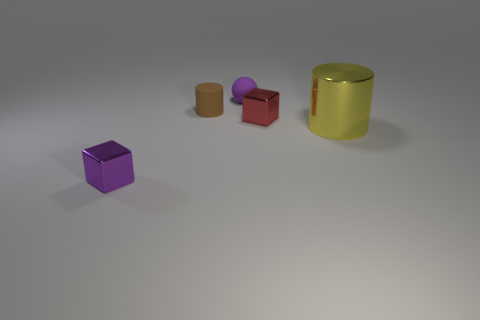Add 1 small purple spheres. How many objects exist? 6 Subtract all purple cubes. How many cubes are left? 1 Subtract 1 yellow cylinders. How many objects are left? 4 Subtract all cubes. How many objects are left? 3 Subtract 1 cylinders. How many cylinders are left? 1 Subtract all brown blocks. Subtract all gray spheres. How many blocks are left? 2 Subtract all blue cylinders. How many yellow spheres are left? 0 Subtract all purple metallic blocks. Subtract all big green metal cubes. How many objects are left? 4 Add 5 tiny brown rubber cylinders. How many tiny brown rubber cylinders are left? 6 Add 5 small metal objects. How many small metal objects exist? 7 